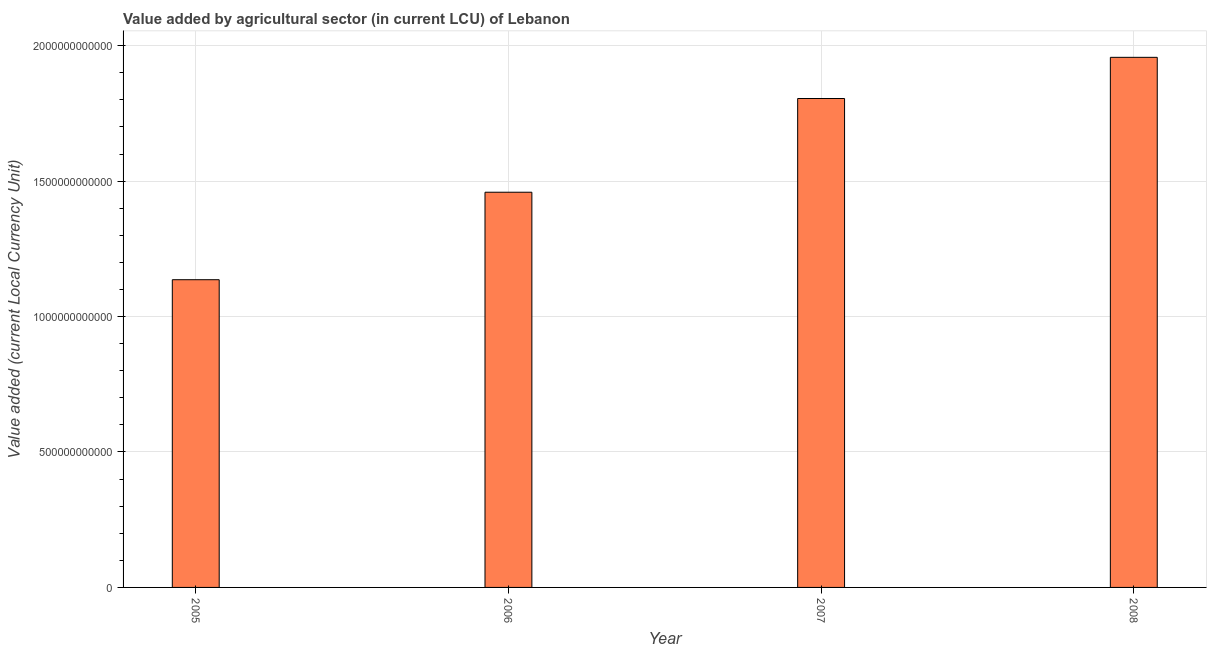Does the graph contain any zero values?
Your answer should be compact. No. What is the title of the graph?
Ensure brevity in your answer.  Value added by agricultural sector (in current LCU) of Lebanon. What is the label or title of the X-axis?
Your response must be concise. Year. What is the label or title of the Y-axis?
Keep it short and to the point. Value added (current Local Currency Unit). What is the value added by agriculture sector in 2006?
Make the answer very short. 1.46e+12. Across all years, what is the maximum value added by agriculture sector?
Ensure brevity in your answer.  1.96e+12. Across all years, what is the minimum value added by agriculture sector?
Ensure brevity in your answer.  1.14e+12. In which year was the value added by agriculture sector maximum?
Provide a succinct answer. 2008. In which year was the value added by agriculture sector minimum?
Ensure brevity in your answer.  2005. What is the sum of the value added by agriculture sector?
Provide a succinct answer. 6.36e+12. What is the difference between the value added by agriculture sector in 2005 and 2006?
Your answer should be compact. -3.23e+11. What is the average value added by agriculture sector per year?
Provide a succinct answer. 1.59e+12. What is the median value added by agriculture sector?
Make the answer very short. 1.63e+12. In how many years, is the value added by agriculture sector greater than 1200000000000 LCU?
Your answer should be very brief. 3. What is the ratio of the value added by agriculture sector in 2005 to that in 2007?
Your answer should be compact. 0.63. What is the difference between the highest and the second highest value added by agriculture sector?
Make the answer very short. 1.52e+11. Is the sum of the value added by agriculture sector in 2006 and 2008 greater than the maximum value added by agriculture sector across all years?
Offer a terse response. Yes. What is the difference between the highest and the lowest value added by agriculture sector?
Offer a terse response. 8.21e+11. In how many years, is the value added by agriculture sector greater than the average value added by agriculture sector taken over all years?
Your response must be concise. 2. What is the difference between two consecutive major ticks on the Y-axis?
Keep it short and to the point. 5.00e+11. Are the values on the major ticks of Y-axis written in scientific E-notation?
Your response must be concise. No. What is the Value added (current Local Currency Unit) of 2005?
Keep it short and to the point. 1.14e+12. What is the Value added (current Local Currency Unit) of 2006?
Provide a succinct answer. 1.46e+12. What is the Value added (current Local Currency Unit) of 2007?
Ensure brevity in your answer.  1.80e+12. What is the Value added (current Local Currency Unit) in 2008?
Offer a terse response. 1.96e+12. What is the difference between the Value added (current Local Currency Unit) in 2005 and 2006?
Your response must be concise. -3.23e+11. What is the difference between the Value added (current Local Currency Unit) in 2005 and 2007?
Provide a short and direct response. -6.69e+11. What is the difference between the Value added (current Local Currency Unit) in 2005 and 2008?
Your response must be concise. -8.21e+11. What is the difference between the Value added (current Local Currency Unit) in 2006 and 2007?
Provide a short and direct response. -3.46e+11. What is the difference between the Value added (current Local Currency Unit) in 2006 and 2008?
Offer a terse response. -4.98e+11. What is the difference between the Value added (current Local Currency Unit) in 2007 and 2008?
Offer a very short reply. -1.52e+11. What is the ratio of the Value added (current Local Currency Unit) in 2005 to that in 2006?
Give a very brief answer. 0.78. What is the ratio of the Value added (current Local Currency Unit) in 2005 to that in 2007?
Ensure brevity in your answer.  0.63. What is the ratio of the Value added (current Local Currency Unit) in 2005 to that in 2008?
Offer a terse response. 0.58. What is the ratio of the Value added (current Local Currency Unit) in 2006 to that in 2007?
Provide a succinct answer. 0.81. What is the ratio of the Value added (current Local Currency Unit) in 2006 to that in 2008?
Give a very brief answer. 0.75. What is the ratio of the Value added (current Local Currency Unit) in 2007 to that in 2008?
Offer a very short reply. 0.92. 